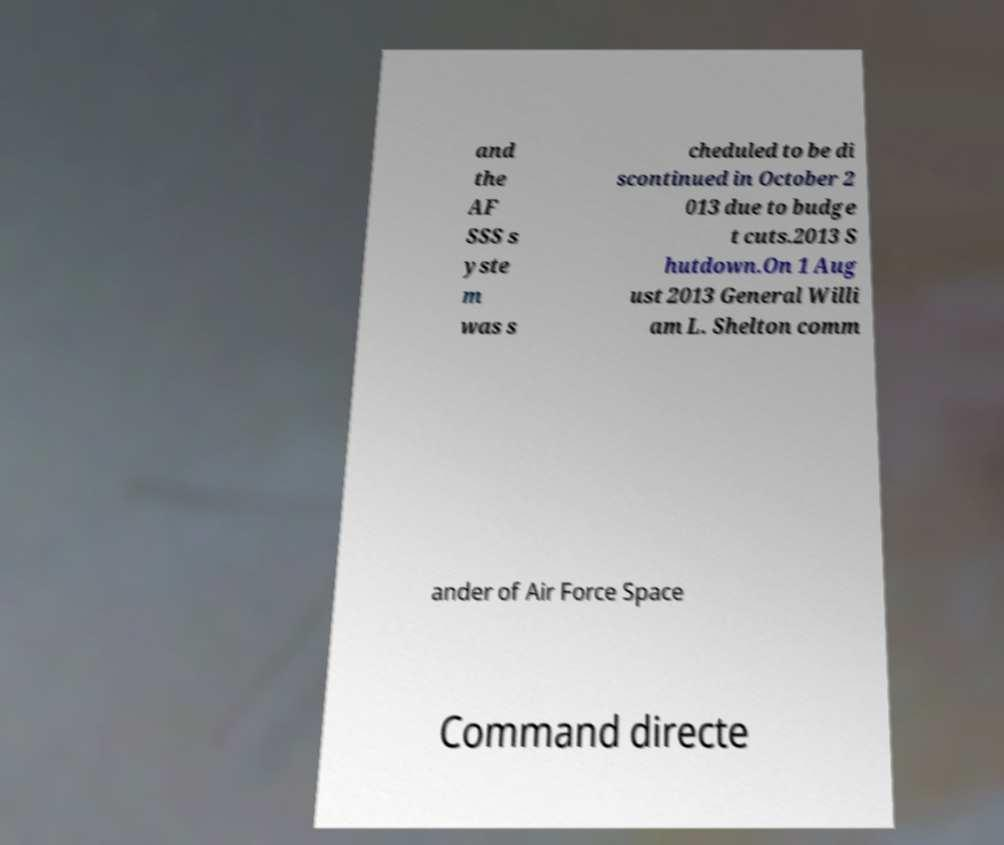There's text embedded in this image that I need extracted. Can you transcribe it verbatim? and the AF SSS s yste m was s cheduled to be di scontinued in October 2 013 due to budge t cuts.2013 S hutdown.On 1 Aug ust 2013 General Willi am L. Shelton comm ander of Air Force Space Command directe 